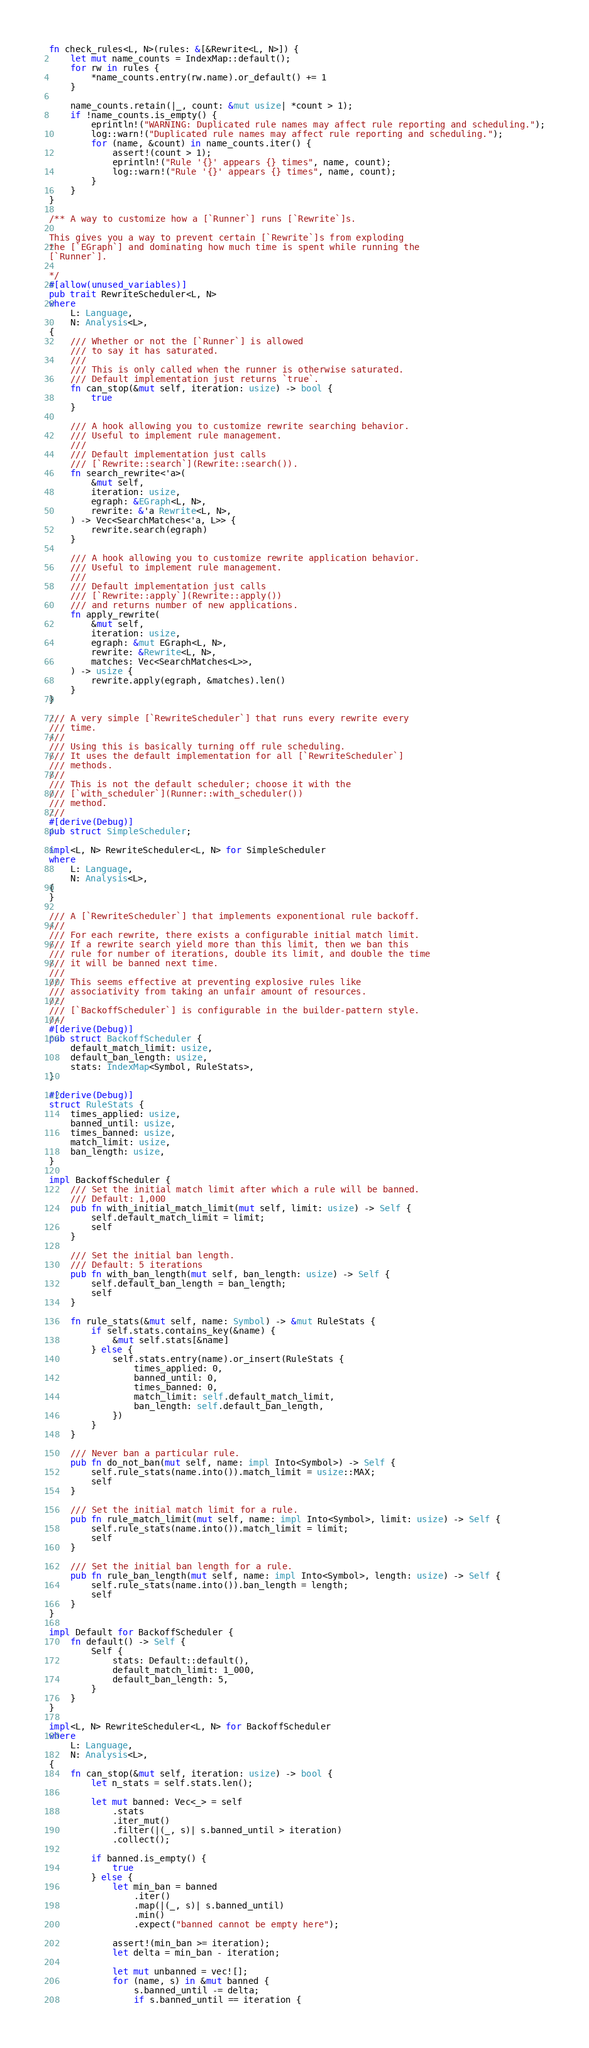<code> <loc_0><loc_0><loc_500><loc_500><_Rust_>
fn check_rules<L, N>(rules: &[&Rewrite<L, N>]) {
    let mut name_counts = IndexMap::default();
    for rw in rules {
        *name_counts.entry(rw.name).or_default() += 1
    }

    name_counts.retain(|_, count: &mut usize| *count > 1);
    if !name_counts.is_empty() {
        eprintln!("WARNING: Duplicated rule names may affect rule reporting and scheduling.");
        log::warn!("Duplicated rule names may affect rule reporting and scheduling.");
        for (name, &count) in name_counts.iter() {
            assert!(count > 1);
            eprintln!("Rule '{}' appears {} times", name, count);
            log::warn!("Rule '{}' appears {} times", name, count);
        }
    }
}

/** A way to customize how a [`Runner`] runs [`Rewrite`]s.

This gives you a way to prevent certain [`Rewrite`]s from exploding
the [`EGraph`] and dominating how much time is spent while running the
[`Runner`].

*/
#[allow(unused_variables)]
pub trait RewriteScheduler<L, N>
where
    L: Language,
    N: Analysis<L>,
{
    /// Whether or not the [`Runner`] is allowed
    /// to say it has saturated.
    ///
    /// This is only called when the runner is otherwise saturated.
    /// Default implementation just returns `true`.
    fn can_stop(&mut self, iteration: usize) -> bool {
        true
    }

    /// A hook allowing you to customize rewrite searching behavior.
    /// Useful to implement rule management.
    ///
    /// Default implementation just calls
    /// [`Rewrite::search`](Rewrite::search()).
    fn search_rewrite<'a>(
        &mut self,
        iteration: usize,
        egraph: &EGraph<L, N>,
        rewrite: &'a Rewrite<L, N>,
    ) -> Vec<SearchMatches<'a, L>> {
        rewrite.search(egraph)
    }

    /// A hook allowing you to customize rewrite application behavior.
    /// Useful to implement rule management.
    ///
    /// Default implementation just calls
    /// [`Rewrite::apply`](Rewrite::apply())
    /// and returns number of new applications.
    fn apply_rewrite(
        &mut self,
        iteration: usize,
        egraph: &mut EGraph<L, N>,
        rewrite: &Rewrite<L, N>,
        matches: Vec<SearchMatches<L>>,
    ) -> usize {
        rewrite.apply(egraph, &matches).len()
    }
}

/// A very simple [`RewriteScheduler`] that runs every rewrite every
/// time.
///
/// Using this is basically turning off rule scheduling.
/// It uses the default implementation for all [`RewriteScheduler`]
/// methods.
///
/// This is not the default scheduler; choose it with the
/// [`with_scheduler`](Runner::with_scheduler())
/// method.
///
#[derive(Debug)]
pub struct SimpleScheduler;

impl<L, N> RewriteScheduler<L, N> for SimpleScheduler
where
    L: Language,
    N: Analysis<L>,
{
}

/// A [`RewriteScheduler`] that implements exponentional rule backoff.
///
/// For each rewrite, there exists a configurable initial match limit.
/// If a rewrite search yield more than this limit, then we ban this
/// rule for number of iterations, double its limit, and double the time
/// it will be banned next time.
///
/// This seems effective at preventing explosive rules like
/// associativity from taking an unfair amount of resources.
///
/// [`BackoffScheduler`] is configurable in the builder-pattern style.
///
#[derive(Debug)]
pub struct BackoffScheduler {
    default_match_limit: usize,
    default_ban_length: usize,
    stats: IndexMap<Symbol, RuleStats>,
}

#[derive(Debug)]
struct RuleStats {
    times_applied: usize,
    banned_until: usize,
    times_banned: usize,
    match_limit: usize,
    ban_length: usize,
}

impl BackoffScheduler {
    /// Set the initial match limit after which a rule will be banned.
    /// Default: 1,000
    pub fn with_initial_match_limit(mut self, limit: usize) -> Self {
        self.default_match_limit = limit;
        self
    }

    /// Set the initial ban length.
    /// Default: 5 iterations
    pub fn with_ban_length(mut self, ban_length: usize) -> Self {
        self.default_ban_length = ban_length;
        self
    }

    fn rule_stats(&mut self, name: Symbol) -> &mut RuleStats {
        if self.stats.contains_key(&name) {
            &mut self.stats[&name]
        } else {
            self.stats.entry(name).or_insert(RuleStats {
                times_applied: 0,
                banned_until: 0,
                times_banned: 0,
                match_limit: self.default_match_limit,
                ban_length: self.default_ban_length,
            })
        }
    }

    /// Never ban a particular rule.
    pub fn do_not_ban(mut self, name: impl Into<Symbol>) -> Self {
        self.rule_stats(name.into()).match_limit = usize::MAX;
        self
    }

    /// Set the initial match limit for a rule.
    pub fn rule_match_limit(mut self, name: impl Into<Symbol>, limit: usize) -> Self {
        self.rule_stats(name.into()).match_limit = limit;
        self
    }

    /// Set the initial ban length for a rule.
    pub fn rule_ban_length(mut self, name: impl Into<Symbol>, length: usize) -> Self {
        self.rule_stats(name.into()).ban_length = length;
        self
    }
}

impl Default for BackoffScheduler {
    fn default() -> Self {
        Self {
            stats: Default::default(),
            default_match_limit: 1_000,
            default_ban_length: 5,
        }
    }
}

impl<L, N> RewriteScheduler<L, N> for BackoffScheduler
where
    L: Language,
    N: Analysis<L>,
{
    fn can_stop(&mut self, iteration: usize) -> bool {
        let n_stats = self.stats.len();

        let mut banned: Vec<_> = self
            .stats
            .iter_mut()
            .filter(|(_, s)| s.banned_until > iteration)
            .collect();

        if banned.is_empty() {
            true
        } else {
            let min_ban = banned
                .iter()
                .map(|(_, s)| s.banned_until)
                .min()
                .expect("banned cannot be empty here");

            assert!(min_ban >= iteration);
            let delta = min_ban - iteration;

            let mut unbanned = vec![];
            for (name, s) in &mut banned {
                s.banned_until -= delta;
                if s.banned_until == iteration {</code> 